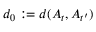<formula> <loc_0><loc_0><loc_500><loc_500>d _ { 0 } \colon = d ( A _ { t } , A _ { t ^ { \prime } } )</formula> 